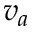Convert formula to latex. <formula><loc_0><loc_0><loc_500><loc_500>v _ { a }</formula> 